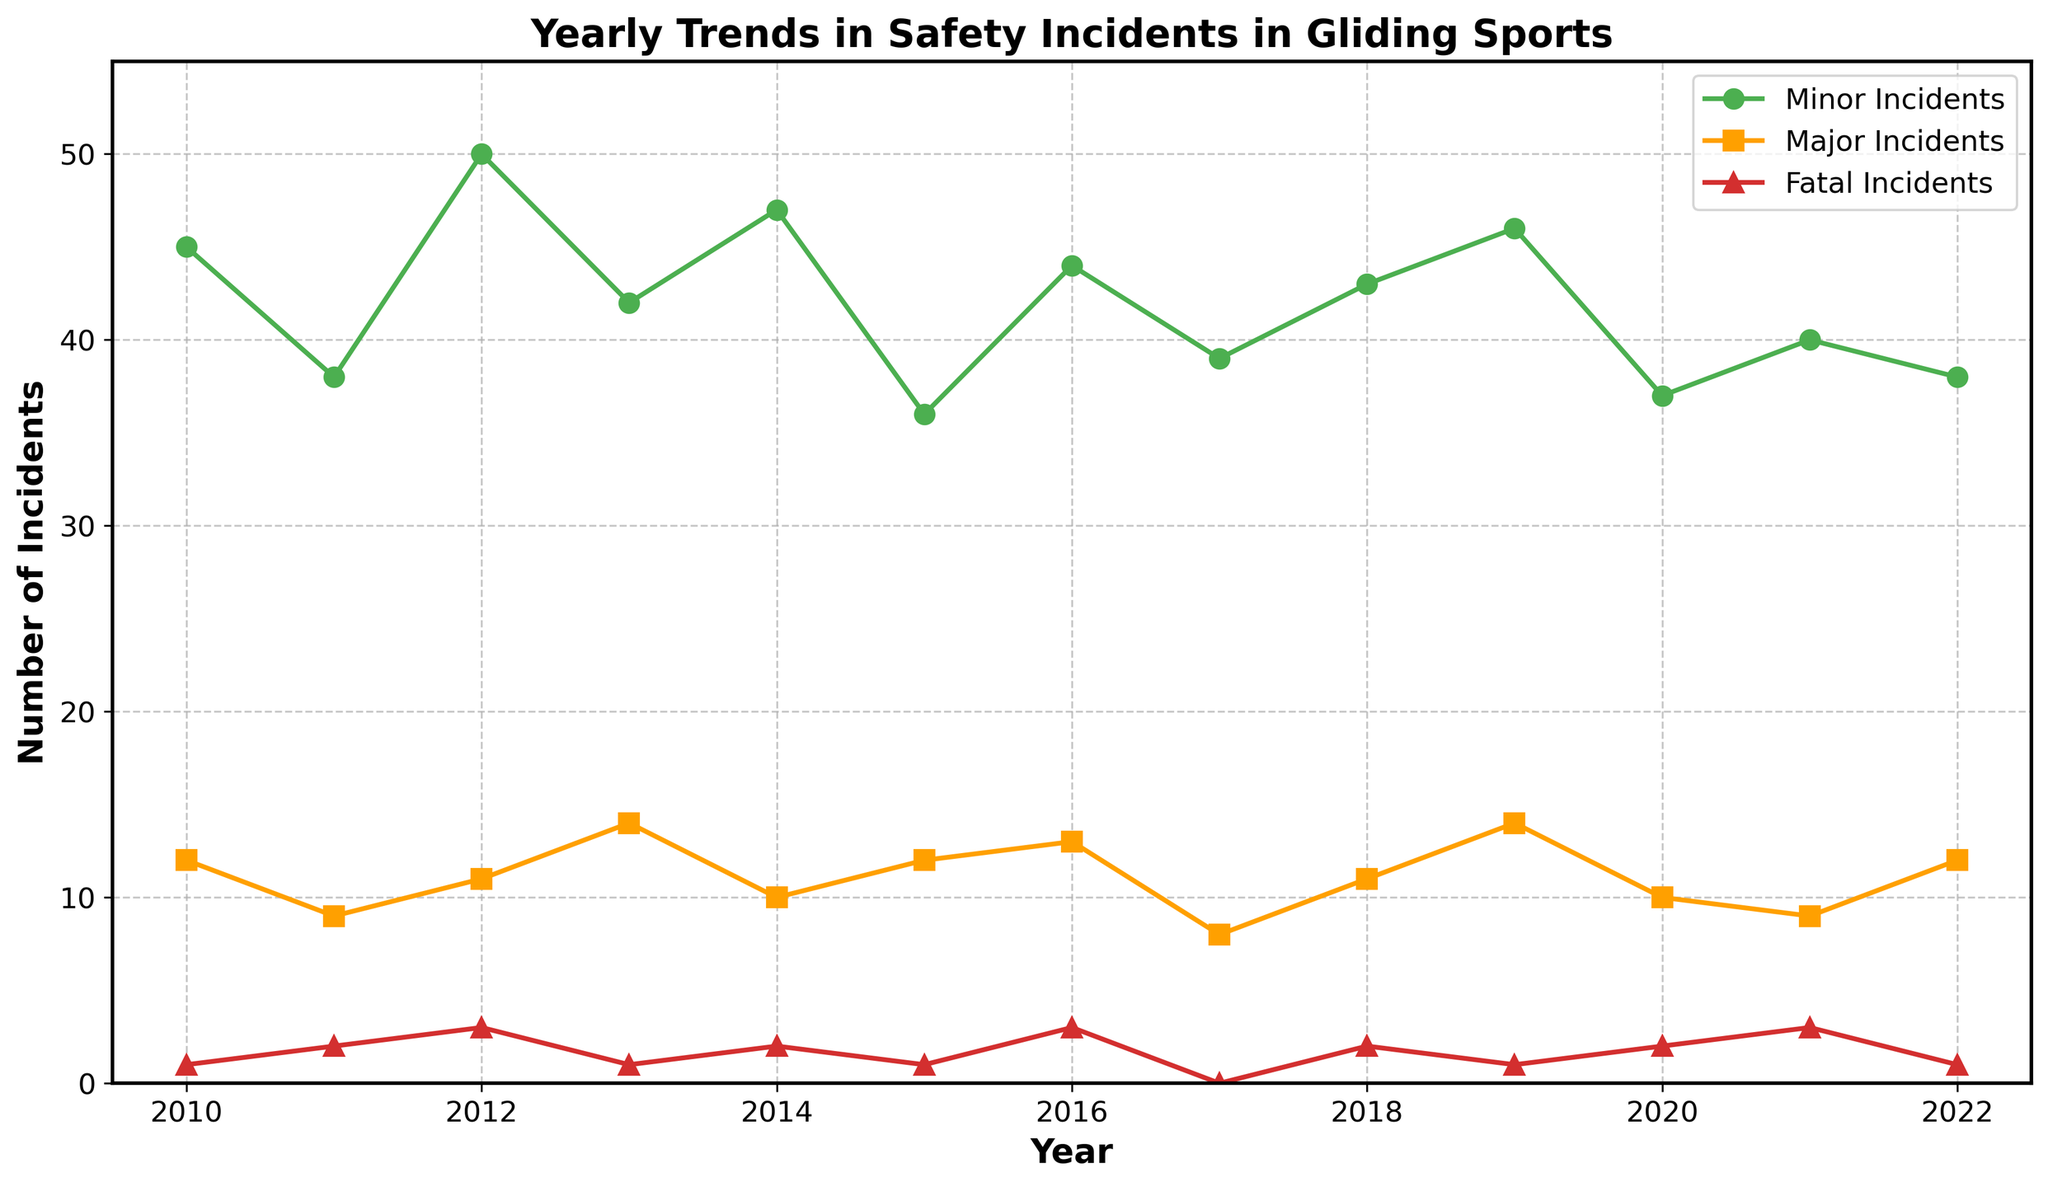What is the title of the figure? The title is usually located at the top of the figure and is written in bold text for emphasis.
Answer: Yearly Trends in Safety Incidents in Gliding Sports How many years are displayed in the figure? Count the number of data points or the x-axis labels, which typically represent the years included in the time series plot.
Answer: 13 How many minor incidents were there in 2015? Locate the year 2015 on the x-axis and follow the corresponding line for minor incidents, marked by circle points, to its value on the y-axis.
Answer: 36 Which year had the highest number of major incidents? Follow the line representing major incidents, marked by square points, and find the maximum value on the y-axis and its corresponding year on the x-axis.
Answer: 2013 and 2019 What is the trend in fatal incidents from 2017 to 2020? Observe the line representing fatal incidents, marked by triangles, from the year 2017 to 2020 to describe the increase or decrease in incidents.
Answer: Increasing How many total incidents (minor + major + fatal) were there in 2012? Sum the values of minor, major, and fatal incidents for the year 2012 found by following the respective lines to their y-axis values. 50 (minor) + 11 (major) + 3 (fatal)
Answer: 64 Which type of incident had the most fluctuations over the years? Look at each line to see which has the most frequent and/or largest changes in its direction and value over the range of years.
Answer: Minor Incidents In which year did all three types of incidents have some occurrence? Find a year where the lines for minor, major, and fatal incidents all have non-zero values.
Answer: 2012 Comparing 2010 and 2022, which type of incident decreased the most? Compare the change in the number of incidents (minor, major, fatal) from 2010 to 2022 by subtracting the 2022 value from the 2010 value for each type and determine which is the greatest decrease.
Answer: Major Incidents What is the average number of major incidents per year? Sum all the values of major incidents and divide by the number of years (13). Sum = 134; Average = 134/13 = 10.31.
Answer: 10.31 